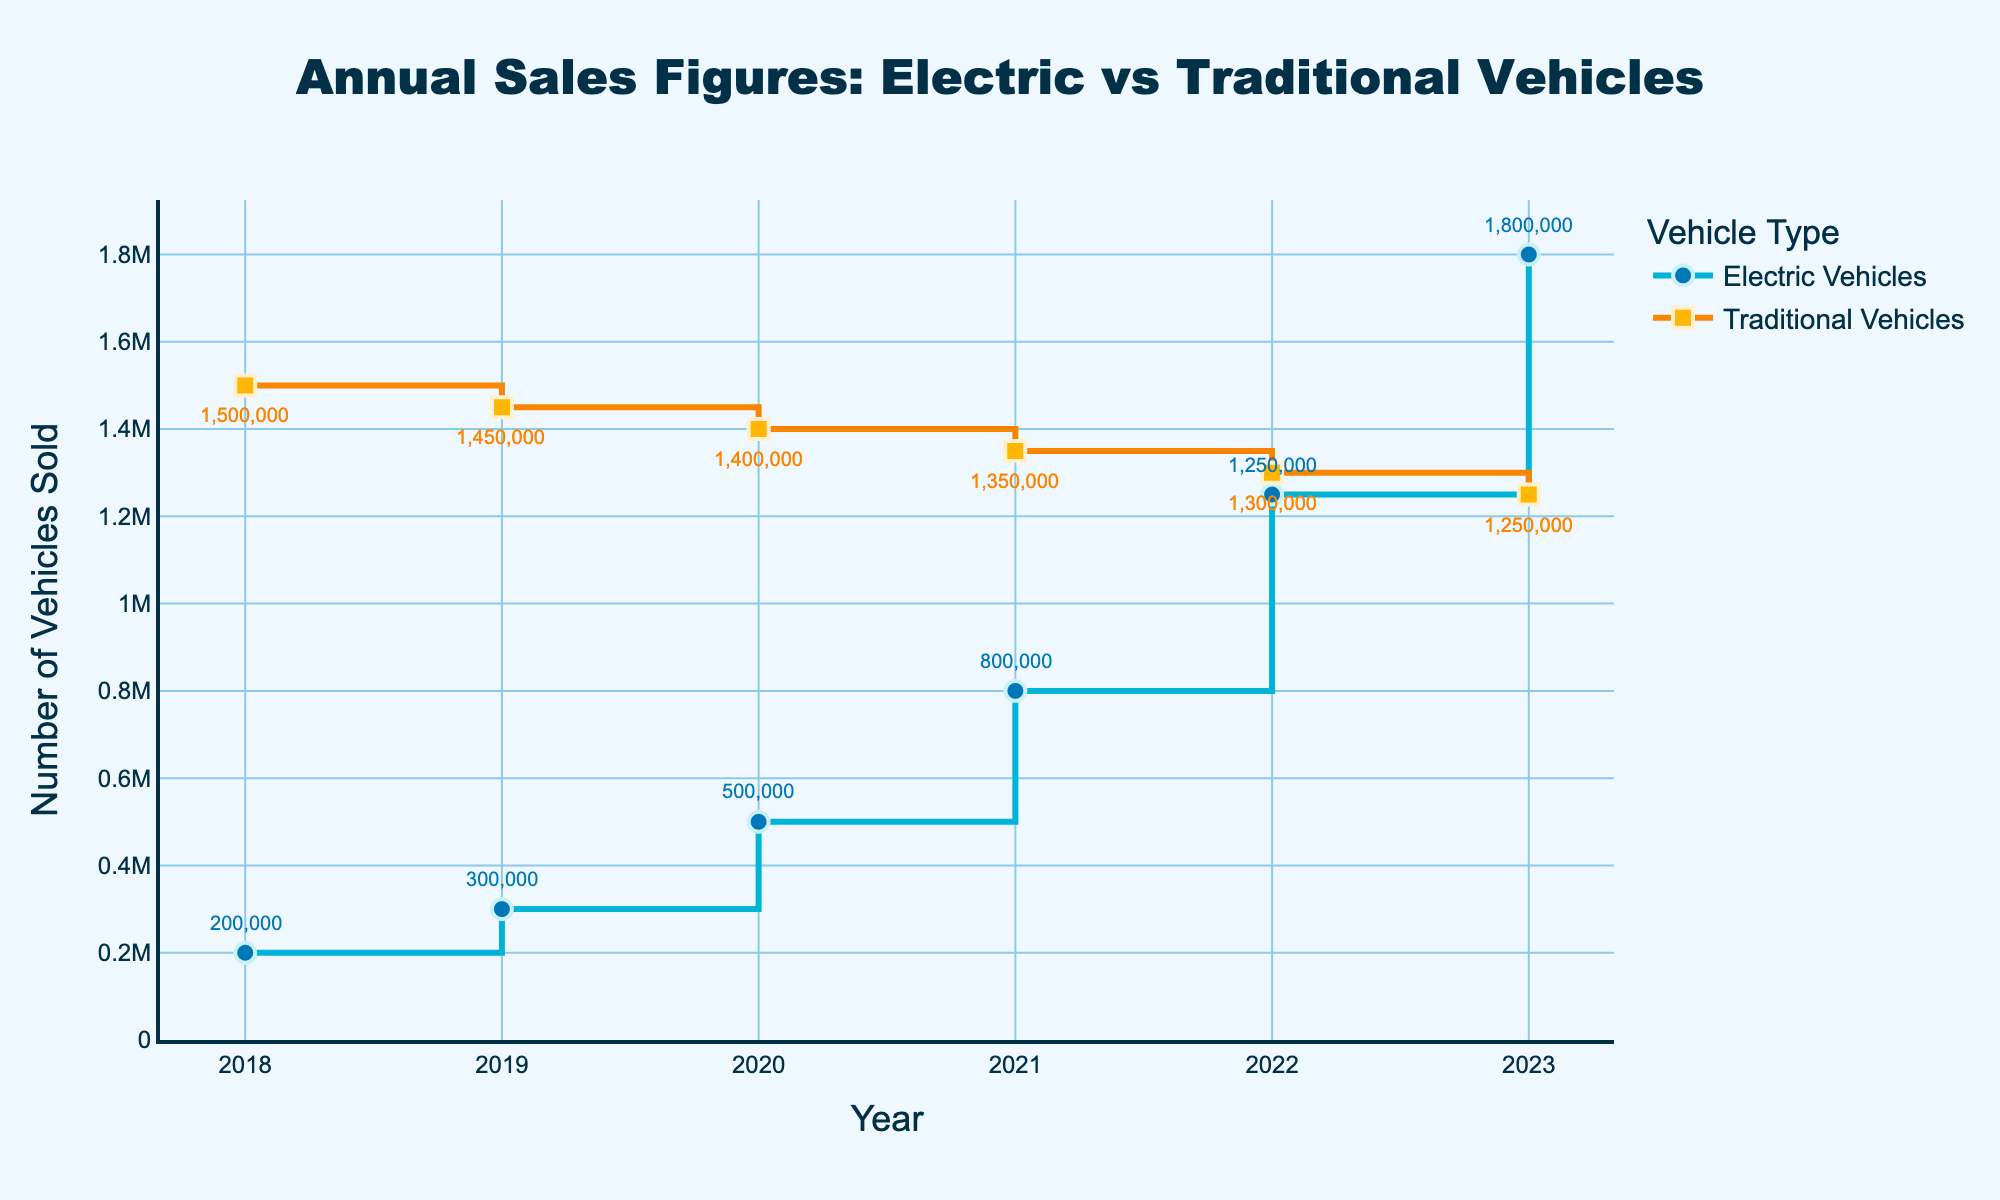How many vehicle types are compared in the graph? The title of the plot "Annual Sales Figures: Electric vs Traditional Vehicles" indicates that two types of vehicles are compared.
Answer: Two What color is used to represent Electric Vehicle sales? The plot highlights Electric Vehicles with a blue-colored line and markers.
Answer: Blue What trend do Electric Vehicle sales show from 2018 to 2023? The sales of Electric Vehicles show a gradual increase every year, moving from 200,000 in 2018 to 1,800,000 in 2023.
Answer: Increasing At which year did Electric Vehicle sales surpass 1,000,000? Reviewing the annotations for Electric Vehicle sales, in 2022, sales reached 1,250,000, surpassing 1,000,000 for the first time.
Answer: 2022 What is the largest sales figure recorded for Traditional Vehicles in the dataset? The largest sales figure for Traditional Vehicles is 1,500,000 in 2018, as seen from the annotations on the graph.
Answer: 1,500,000 By how much did Electric Vehicle sales increase from 2020 to 2022? The Electric Vehicle sales were 500,000 in 2020 and increased to 1,250,000 in 2022. Calculating 1,250,000 minus 500,000 gives the increase.
Answer: 750,000 How many total vehicles were sold in 2021? Combining both vehicle types, 800,000 Electric Vehicles and 1,350,000 Traditional Vehicles were sold in 2021, summing up to 2,150,000.
Answer: 2,150,000 When did Electric Vehicles and Traditional Vehicles have nearly equal sales figures? Comparing the stair plots, in 2023, Electric Vehicle sales were 1,800,000 while Traditional Vehicle sales were relatively close at 1,250,000.
Answer: 2023 Which year had the smallest gap between Electric and Traditional Vehicle sales? Evaluating yearly differences, in 2023, the gap between Electric (1,800,000) and Traditional (1,250,000) Vehicle sales was the smallest, at 550,000.
Answer: 2023 What overall trend can be seen in Traditional Vehicle sales from 2018 to 2023? From 2018 to 2023, Traditional Vehicle sales show a steady decline each year, decreasing from 1,500,000 to 1,250,000.
Answer: Decreasing 